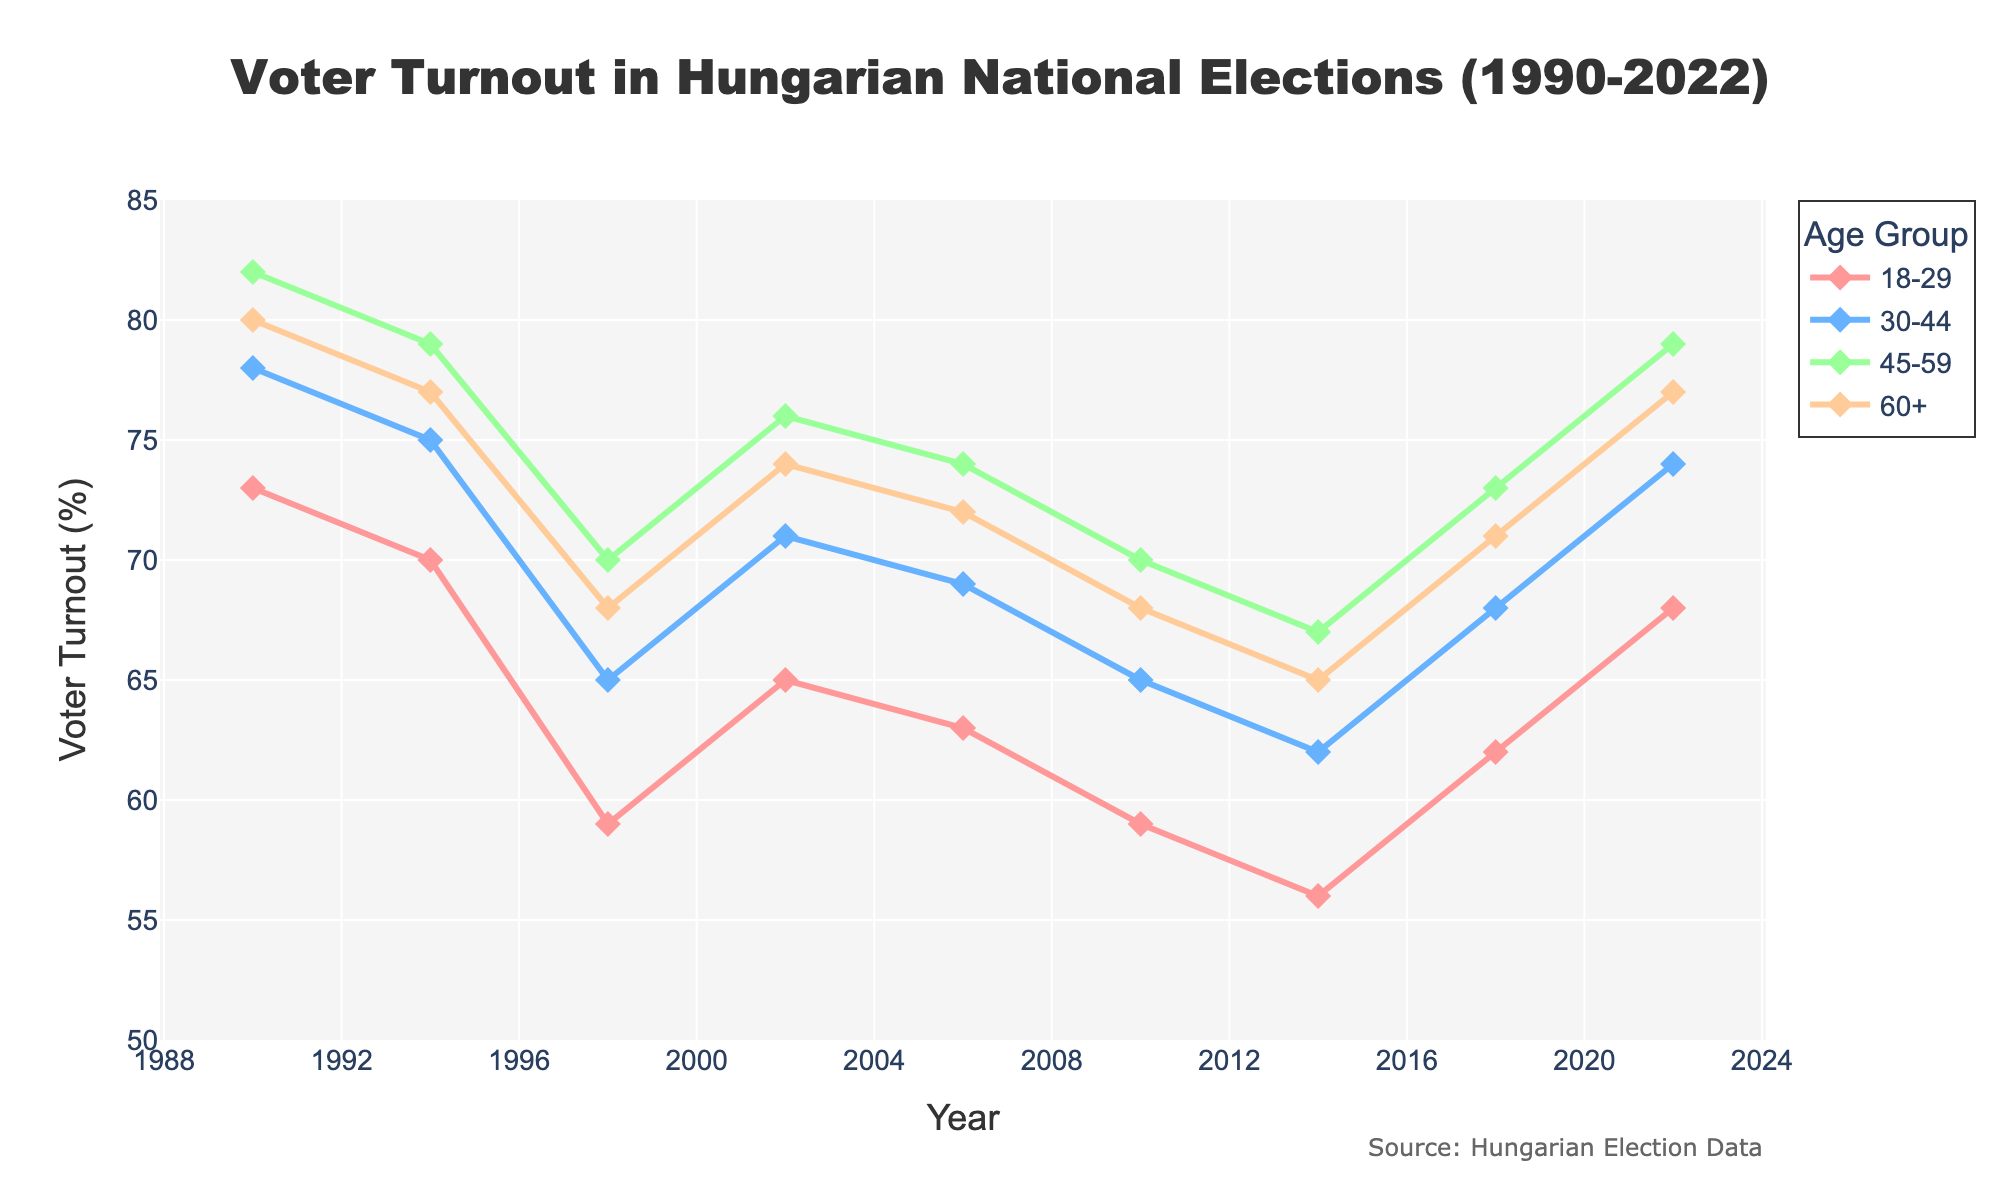What was the voter turnout for the 18-29 age group in 2014? Locate the year 2014 on the x-axis and find the corresponding point for the 18-29 age group.
Answer: 56 In which year did the 60+ age group have the highest turnout? Scan the line that represents the 60+ age group and identify the highest point, then find the corresponding year on the x-axis.
Answer: 1990 Which age group had the largest increase in voter turnout between 2014 and 2022? Calculate the difference in turnout between 2014 and 2022 for each age group, then compare the differences. 18-29: 68-56 = 12; 30-44: 74-62 = 12; 45-59: 79-67 = 12; 60+: 77-65 = 12. All increases are equal.
Answer: All age groups By how much did the voter turnout for the 30-44 age group change from 2010 to 2018? Subtract the voter turnout in 2010 from that in 2018 for the 30-44 age group. 68 - 65 = 3
Answer: 3 Which age group consistently had the highest voter turnout from 1990 to 2022? Compare the lines representing each age group over the entire period to see which one consistently stays at the top.
Answer: 45-59 In which year did the 18-29 age group's voter turnout hit its lowest point? Identify the lowest point on the line representing the 18-29 age group and find the corresponding year.
Answer: 2014 What is the average voter turnout for the 60+ age group across all years? Sum the voter turnout values for the 60+ age group and divide by the number of years (9). (80+77+68+74+72+68+65+71+77)/9 = 72.44
Answer: 72.44 Which two age groups had the closest voter turnout rates in 2010? Compare the voter turnout rates for all age groups in 2010. 18-29: 59, 30-44: 65, 45-59: 70, 60+: 68. The closest rates are 45-59 and 60+: 2
Answer: 45-59 and 60+ Is there any age group whose voter turnout never exceeds that of other groups in any year? Examine each age group line to see if it ever intersects the other lines to rise above them. The 18-29 age group line never exceeds any other age group.
Answer: 18-29 How did voter turnout for the 60+ age group change from 1990 to 2014? Compare the voter turnout in 1990 and 2014 for the 60+ age group. 80 - 65 = 15 (a decrease by 15 percentage points)
Answer: Decreased by 15 